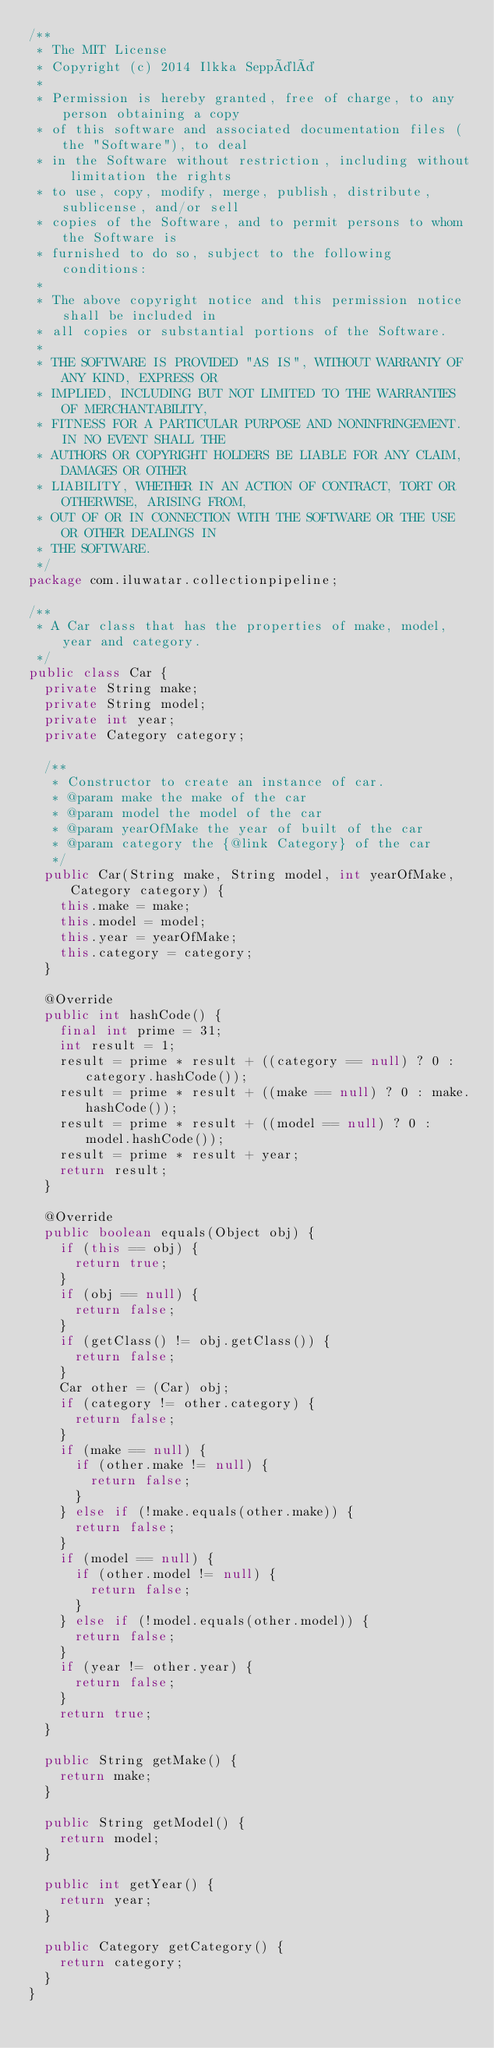<code> <loc_0><loc_0><loc_500><loc_500><_Java_>/**
 * The MIT License
 * Copyright (c) 2014 Ilkka Seppälä
 *
 * Permission is hereby granted, free of charge, to any person obtaining a copy
 * of this software and associated documentation files (the "Software"), to deal
 * in the Software without restriction, including without limitation the rights
 * to use, copy, modify, merge, publish, distribute, sublicense, and/or sell
 * copies of the Software, and to permit persons to whom the Software is
 * furnished to do so, subject to the following conditions:
 *
 * The above copyright notice and this permission notice shall be included in
 * all copies or substantial portions of the Software.
 *
 * THE SOFTWARE IS PROVIDED "AS IS", WITHOUT WARRANTY OF ANY KIND, EXPRESS OR
 * IMPLIED, INCLUDING BUT NOT LIMITED TO THE WARRANTIES OF MERCHANTABILITY,
 * FITNESS FOR A PARTICULAR PURPOSE AND NONINFRINGEMENT. IN NO EVENT SHALL THE
 * AUTHORS OR COPYRIGHT HOLDERS BE LIABLE FOR ANY CLAIM, DAMAGES OR OTHER
 * LIABILITY, WHETHER IN AN ACTION OF CONTRACT, TORT OR OTHERWISE, ARISING FROM,
 * OUT OF OR IN CONNECTION WITH THE SOFTWARE OR THE USE OR OTHER DEALINGS IN
 * THE SOFTWARE.
 */
package com.iluwatar.collectionpipeline;

/**
 * A Car class that has the properties of make, model, year and category.
 */
public class Car {
  private String make;
  private String model;
  private int year;
  private Category category;

  /**
   * Constructor to create an instance of car.
   * @param make the make of the car
   * @param model the model of the car
   * @param yearOfMake the year of built of the car
   * @param category the {@link Category} of the car
   */
  public Car(String make, String model, int yearOfMake, Category category) {
    this.make = make;
    this.model = model;
    this.year = yearOfMake;
    this.category = category;
  }

  @Override
  public int hashCode() {
    final int prime = 31;
    int result = 1;
    result = prime * result + ((category == null) ? 0 : category.hashCode());
    result = prime * result + ((make == null) ? 0 : make.hashCode());
    result = prime * result + ((model == null) ? 0 : model.hashCode());
    result = prime * result + year;
    return result;
  }

  @Override
  public boolean equals(Object obj) {
    if (this == obj) {
      return true;
    }
    if (obj == null) {
      return false;
    }
    if (getClass() != obj.getClass()) {
      return false;
    }
    Car other = (Car) obj;
    if (category != other.category) {
      return false;
    }
    if (make == null) {
      if (other.make != null) {
        return false;
      }
    } else if (!make.equals(other.make)) {
      return false;
    }
    if (model == null) {
      if (other.model != null) {
        return false;
      }
    } else if (!model.equals(other.model)) {
      return false;
    }
    if (year != other.year) {
      return false;
    }
    return true;
  }

  public String getMake() {
    return make;
  }

  public String getModel() {
    return model;
  }

  public int getYear() {
    return year;
  }
  
  public Category getCategory() {
    return category;
  }
}</code> 